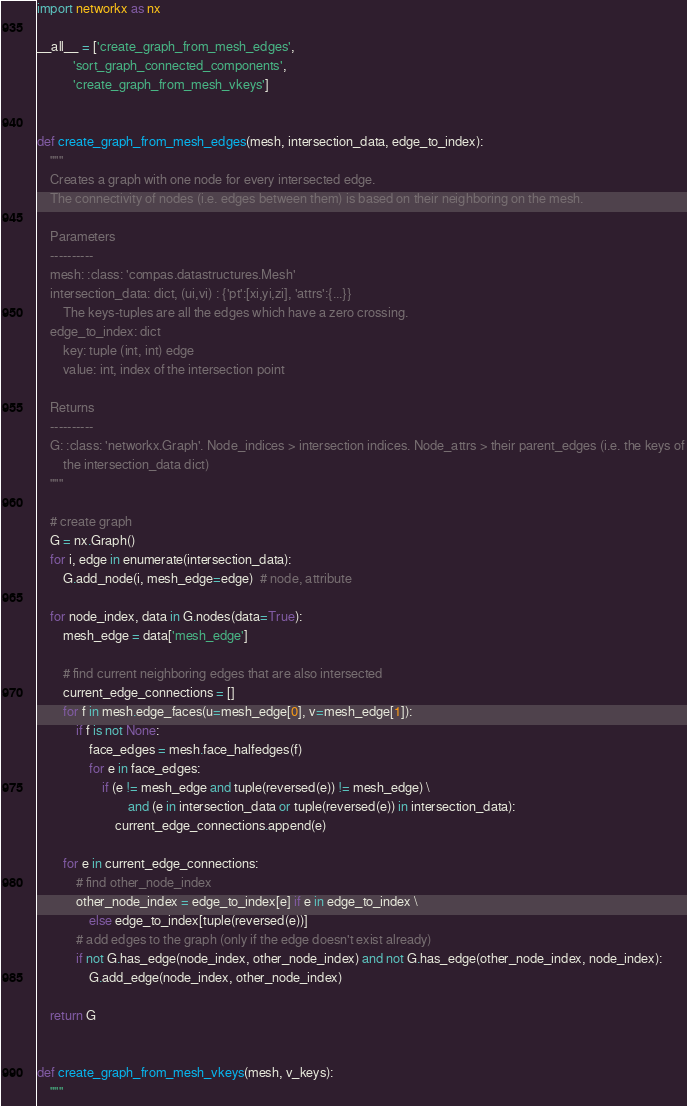<code> <loc_0><loc_0><loc_500><loc_500><_Python_>import networkx as nx

__all__ = ['create_graph_from_mesh_edges',
           'sort_graph_connected_components',
           'create_graph_from_mesh_vkeys']


def create_graph_from_mesh_edges(mesh, intersection_data, edge_to_index):
    """
    Creates a graph with one node for every intersected edge.
    The connectivity of nodes (i.e. edges between them) is based on their neighboring on the mesh.

    Parameters
    ----------
    mesh: :class: 'compas.datastructures.Mesh'
    intersection_data: dict, (ui,vi) : {'pt':[xi,yi,zi], 'attrs':{...}}
        The keys-tuples are all the edges which have a zero crossing.
    edge_to_index: dict
        key: tuple (int, int) edge
        value: int, index of the intersection point

    Returns
    ----------
    G: :class: 'networkx.Graph'. Node_indices > intersection indices. Node_attrs > their parent_edges (i.e. the keys of
        the intersection_data dict)
    """

    # create graph
    G = nx.Graph()
    for i, edge in enumerate(intersection_data):
        G.add_node(i, mesh_edge=edge)  # node, attribute

    for node_index, data in G.nodes(data=True):
        mesh_edge = data['mesh_edge']

        # find current neighboring edges that are also intersected
        current_edge_connections = []
        for f in mesh.edge_faces(u=mesh_edge[0], v=mesh_edge[1]):
            if f is not None:
                face_edges = mesh.face_halfedges(f)
                for e in face_edges:
                    if (e != mesh_edge and tuple(reversed(e)) != mesh_edge) \
                            and (e in intersection_data or tuple(reversed(e)) in intersection_data):
                        current_edge_connections.append(e)

        for e in current_edge_connections:
            # find other_node_index
            other_node_index = edge_to_index[e] if e in edge_to_index \
                else edge_to_index[tuple(reversed(e))]
            # add edges to the graph (only if the edge doesn't exist already)
            if not G.has_edge(node_index, other_node_index) and not G.has_edge(other_node_index, node_index):
                G.add_edge(node_index, other_node_index)

    return G


def create_graph_from_mesh_vkeys(mesh, v_keys):
    """</code> 